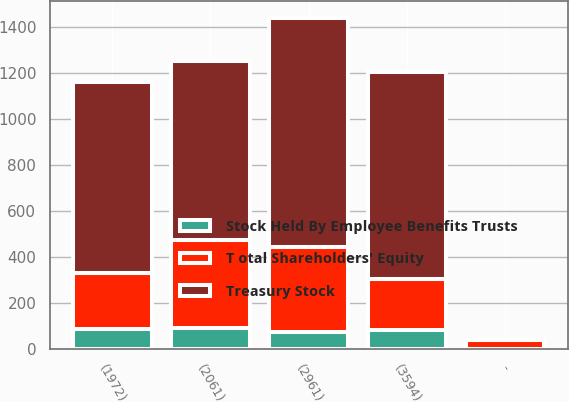Convert chart. <chart><loc_0><loc_0><loc_500><loc_500><stacked_bar_chart><ecel><fcel>(2061)<fcel>-<fcel>(1972)<fcel>(3594)<fcel>(2961)<nl><fcel>Treasury Stock<fcel>779<fcel>0.5<fcel>828<fcel>899.7<fcel>995.5<nl><fcel>Stock Held By Employee Benefits Trusts<fcel>90.3<fcel>0.5<fcel>89.8<fcel>82.4<fcel>73.9<nl><fcel>T otal Shareholders' Equity<fcel>383.6<fcel>37.7<fcel>243.5<fcel>221<fcel>371.5<nl></chart> 